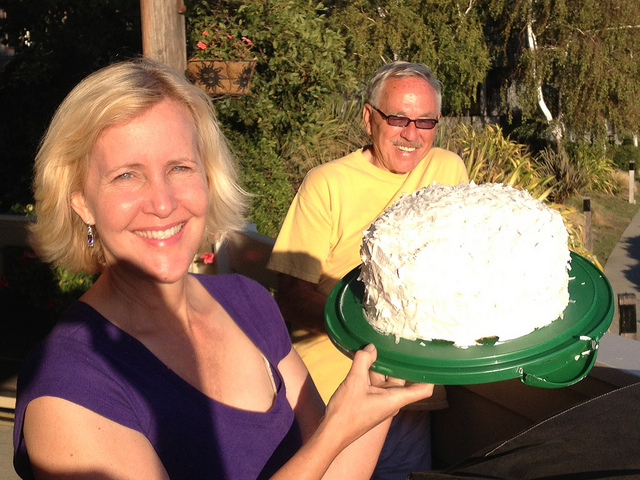Describe the setting of this photo. The photo appears to be taken outdoors, possibly in a garden or patio area with greenery in the background. It's a sunny day, and the lighting suggests it could be late afternoon or early evening. What details indicate the time of day? The shadows are elongated and the warm glow on their faces suggests the sun is low in the sky, characteristic of late afternoon or evening before sunset. 